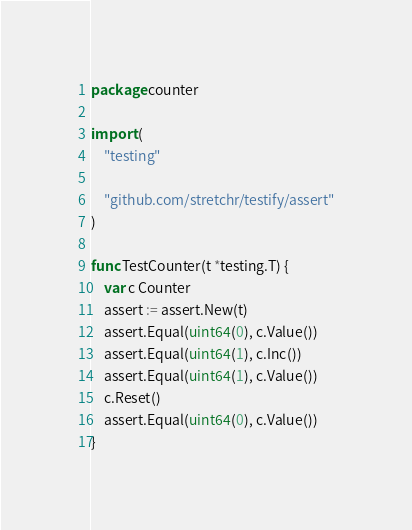<code> <loc_0><loc_0><loc_500><loc_500><_Go_>package counter

import (
	"testing"

	"github.com/stretchr/testify/assert"
)

func TestCounter(t *testing.T) {
	var c Counter
	assert := assert.New(t)
	assert.Equal(uint64(0), c.Value())
	assert.Equal(uint64(1), c.Inc())
	assert.Equal(uint64(1), c.Value())
	c.Reset()
	assert.Equal(uint64(0), c.Value())
}
</code> 